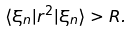Convert formula to latex. <formula><loc_0><loc_0><loc_500><loc_500>\langle \xi _ { n } | r ^ { 2 } | \xi _ { n } \rangle > R .</formula> 